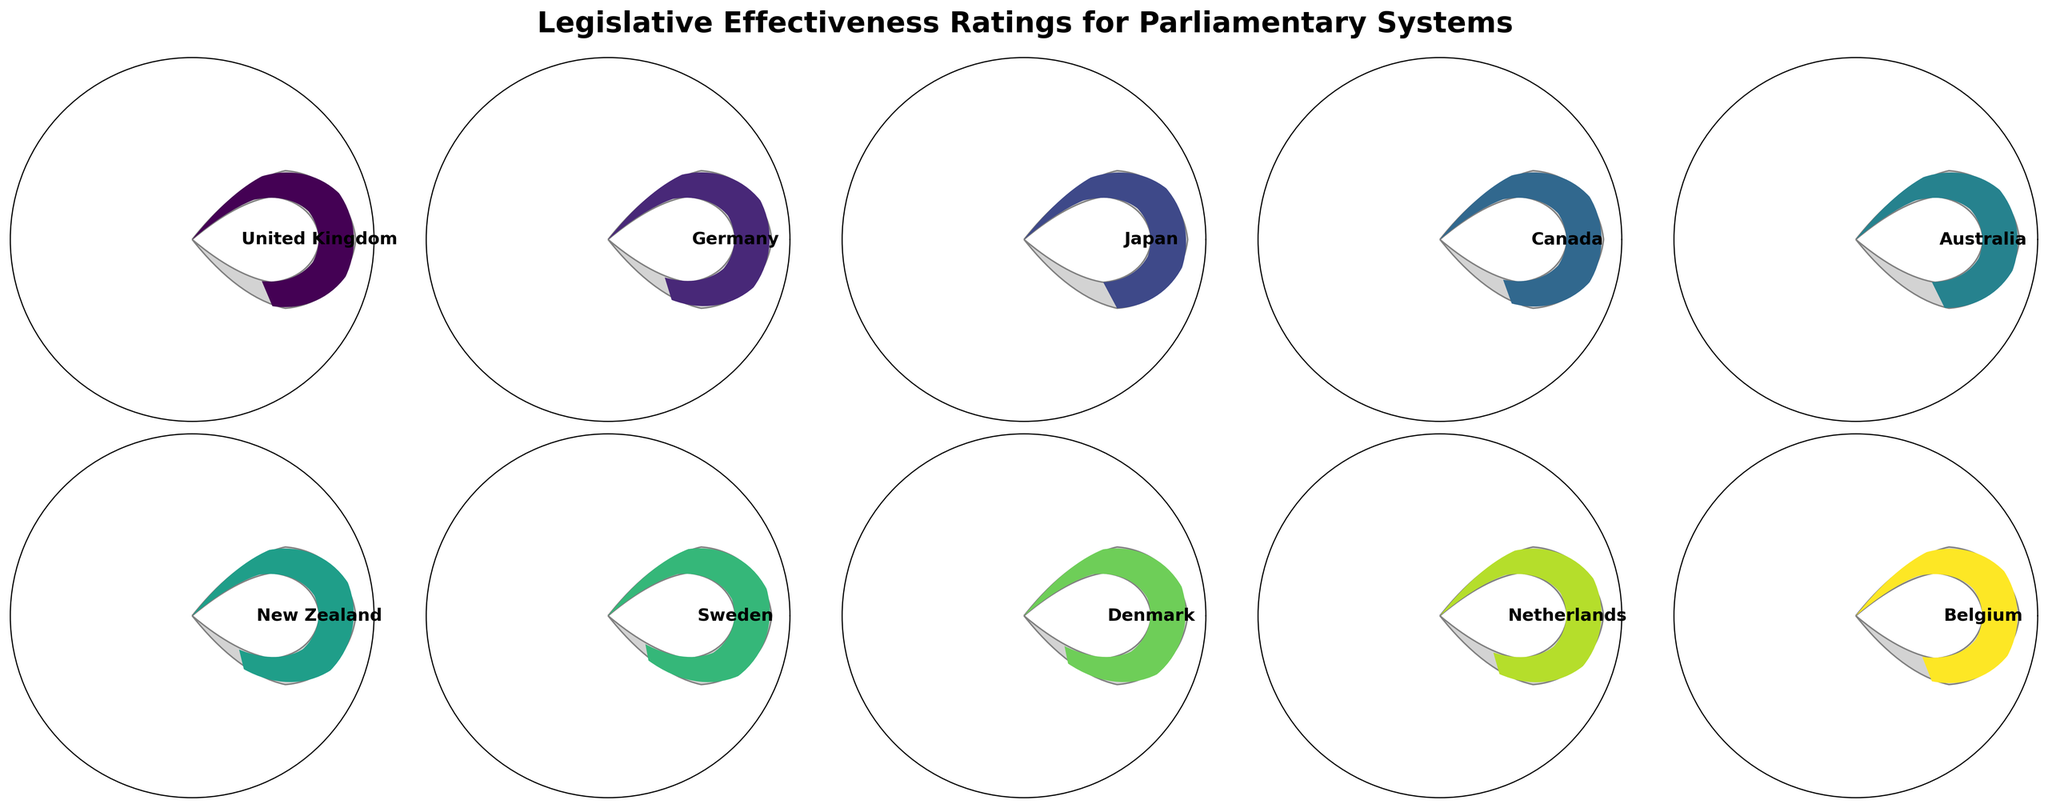what is the title of the figure? The title is usually displayed prominently at the top of the figure. Here it states "Legislative Effectiveness Ratings for Parliamentary Systems" in bold font, indicating what the figure is about.
Answer: Legislative Effectiveness Ratings for Parliamentary Systems How many countries are displayed in the figure? You can count the number of individual gauge charts presented in the figure. Each gauge chart corresponds to one country.
Answer: 10 Which country has the highest legislative effectiveness score? By looking at the scores displayed on each gauge chart, it's easy to determine that Sweden has the highest legislative effectiveness score of 88.
Answer: Sweden Which country has the lowest legislative effectiveness score? By comparing the scores displayed on each gauge chart, it is evident that Japan has the lowest score with 75.
Answer: Japan What is the average legislative effectiveness score of all countries? To find the average score, sum up all the individual scores and divide by the number of countries. Thus, (78 + 82 + 75 + 80 + 76 + 85 + 88 + 87 + 83 + 79) / 10 = 81.3
Answer: 81.3 Is there any country with a legislative effectiveness score greater than or equal to 85? Checking each gauge chart and the corresponding scores, we find that New Zealand and Sweden have scores equal to or greater than 85.
Answer: Yes, New Zealand and Sweden Which countries have a legislative effectiveness score between 75 and 80? Identifying the scores within the specified range, we find that Japan, Australia, and Belgium fall between 75 and 80.
Answer: Japan, Australia, Belgium What is the median legislative effectiveness score? To find the median score, list all the scores in ascending order and find the middle value. The scores are: 75, 76, 78, 79, 80, 82, 83, 85, 87, 88. The middle values are 80 and 82, so the median is the average of these two: (80 + 82) / 2 = 81.
Answer: 81 How many countries have a legislative effectiveness score above 80? Count all gauge charts with scores above 80. The countries are Germany, Canada, New Zealand, Sweden, Denmark, and Netherlands, which totals six countries.
Answer: 6 What colors are used in the gauge charts to represent different countries? Each country's gauge has a distinct color chosen from a viridis colormap, ranging from light to dark shades. Specific colors are not named but can be visually differentiated.
Answer: Various colors from light to dark shades Which two countries have legislative effectiveness scores closest to each other? Observing the scores, we see that the Netherlands has 83, and Germany has 82. The difference is the smallest, being just 1.
Answer: Netherlands and Germany 